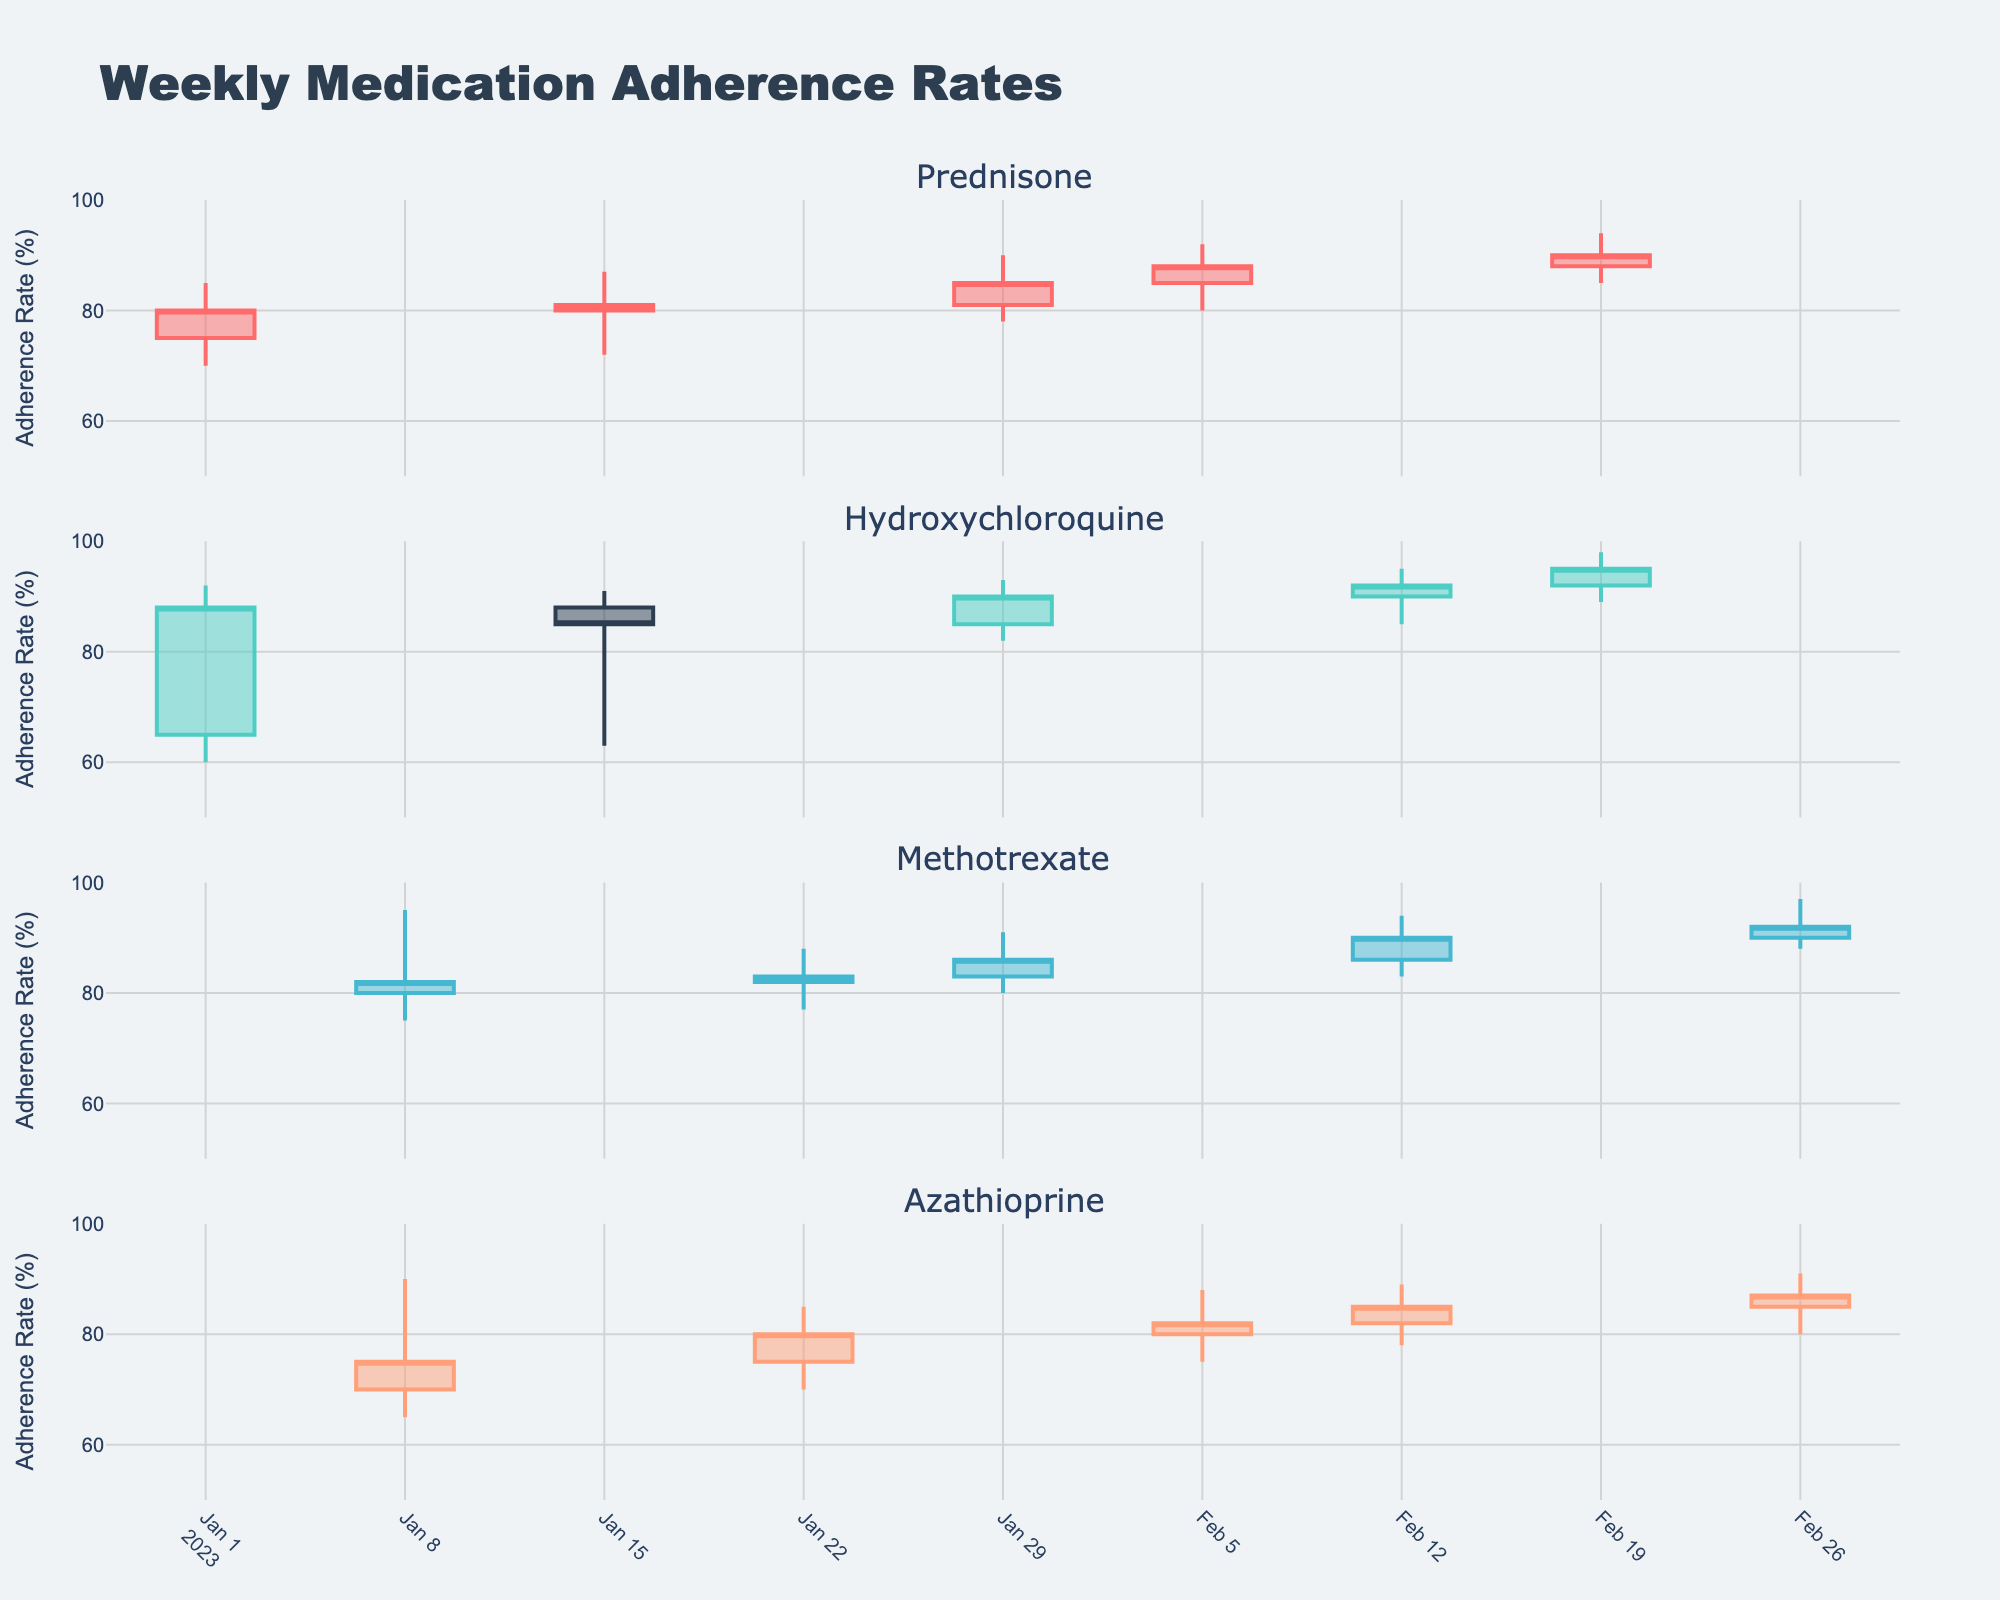What's the title of the figure? The title is usually written at the top of the figure for easy identification. Here, it is labeled clearly in the center.
Answer: Weekly Medication Adherence Rates How many medications are tracked in this figure? Each subplot title represents a different medication. Count these titles for the total number of medications.
Answer: 4 Which medication had the highest adherence rate in the week of 2023-02-26? Look at the high values for each medication subplot for the week of 2023-02-26 and compare them.
Answer: Methotrexate Which medication has the most significant variation in adherence rate in any given week? Identify the medication with the largest difference between high and low values in any week. This difference indicates the range of adherence rate variation.
Answer: Hydroxychloroquine For Prednisone, did the adherence rate increase or decrease in the week of 2023-01-29? For candlestick charts, if the close value is higher than the open value, it indicates an increase. If lower, it indicates a decrease. Check the open and close values for Prednisone on that week.
Answer: Increase What is the overall trend of Methotrexate's adherence rate from the beginning of January to the end of February? Track the closing values of Methotrexate across the weeks to determine if they are generally increasing, decreasing, or stable.
Answer: Increasing Which week saw the highest adherence rate for Azathioprine? Look for the highest high value across all weeks for the medication Azathioprine.
Answer: 2023-02-26 Between 2023-01-01 and 2023-01-15, which medication saw a decrease in adherence rates? Compare the closing values to the opening values for these weeks. If a medication's close value is lower than its open value, it decreased.
Answer: Hydroxychloroquine Was there any week where all medications had an increasing adherence rate? Check each subplot for a week where the close value is higher than the open value for all medications.
Answer: 2023-01-29 For Hydroxychloroquine, in which week was the difference between the high and low values the highest? Calculate the difference between high and low values for each week and compare to find the maximum difference for Hydroxychloroquine.
Answer: 2023-01-01 